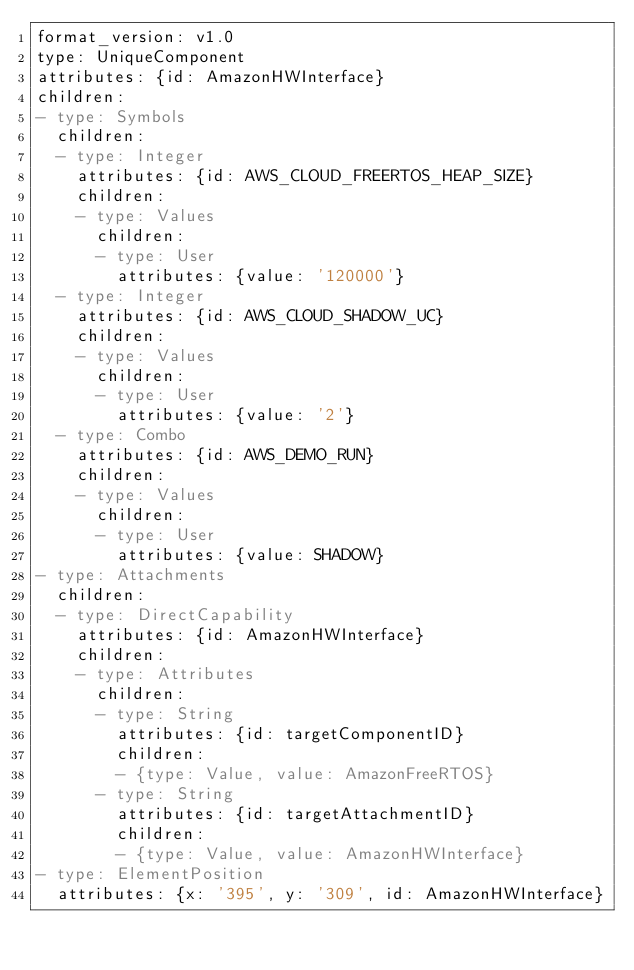Convert code to text. <code><loc_0><loc_0><loc_500><loc_500><_YAML_>format_version: v1.0
type: UniqueComponent
attributes: {id: AmazonHWInterface}
children:
- type: Symbols
  children:
  - type: Integer
    attributes: {id: AWS_CLOUD_FREERTOS_HEAP_SIZE}
    children:
    - type: Values
      children:
      - type: User
        attributes: {value: '120000'}
  - type: Integer
    attributes: {id: AWS_CLOUD_SHADOW_UC}
    children:
    - type: Values
      children:
      - type: User
        attributes: {value: '2'}
  - type: Combo
    attributes: {id: AWS_DEMO_RUN}
    children:
    - type: Values
      children:
      - type: User
        attributes: {value: SHADOW}
- type: Attachments
  children:
  - type: DirectCapability
    attributes: {id: AmazonHWInterface}
    children:
    - type: Attributes
      children:
      - type: String
        attributes: {id: targetComponentID}
        children:
        - {type: Value, value: AmazonFreeRTOS}
      - type: String
        attributes: {id: targetAttachmentID}
        children:
        - {type: Value, value: AmazonHWInterface}
- type: ElementPosition
  attributes: {x: '395', y: '309', id: AmazonHWInterface}
</code> 